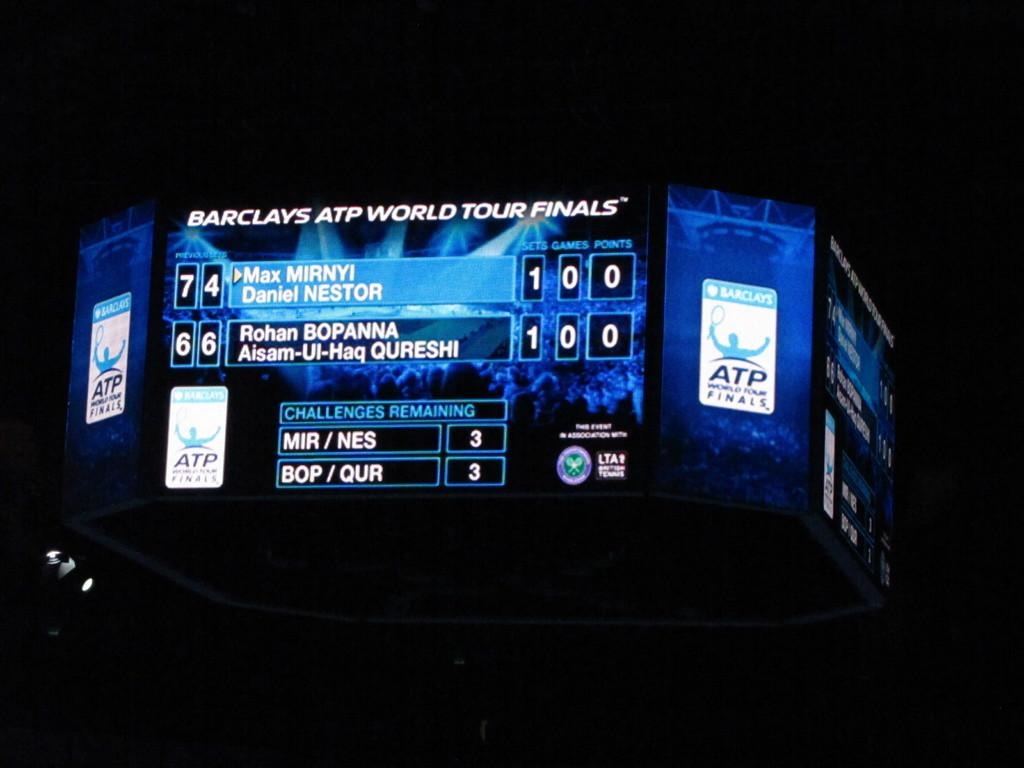<image>
Render a clear and concise summary of the photo. The scoreboard at the Barclays ATP World Tour Finals shows a tie score. 